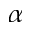<formula> <loc_0><loc_0><loc_500><loc_500>\alpha</formula> 